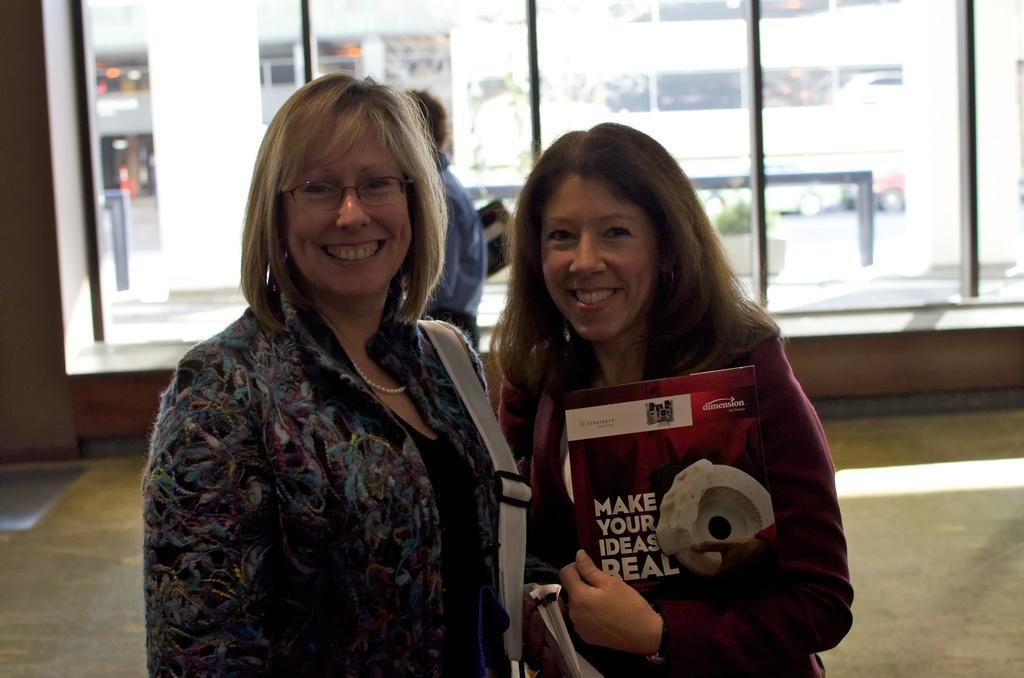Describe this image in one or two sentences. In the foreground of the picture there are two women, they are smiling. In the center of the picture there are windows and a person, outside the windows we can see buildings, plant, vehicles and road. 